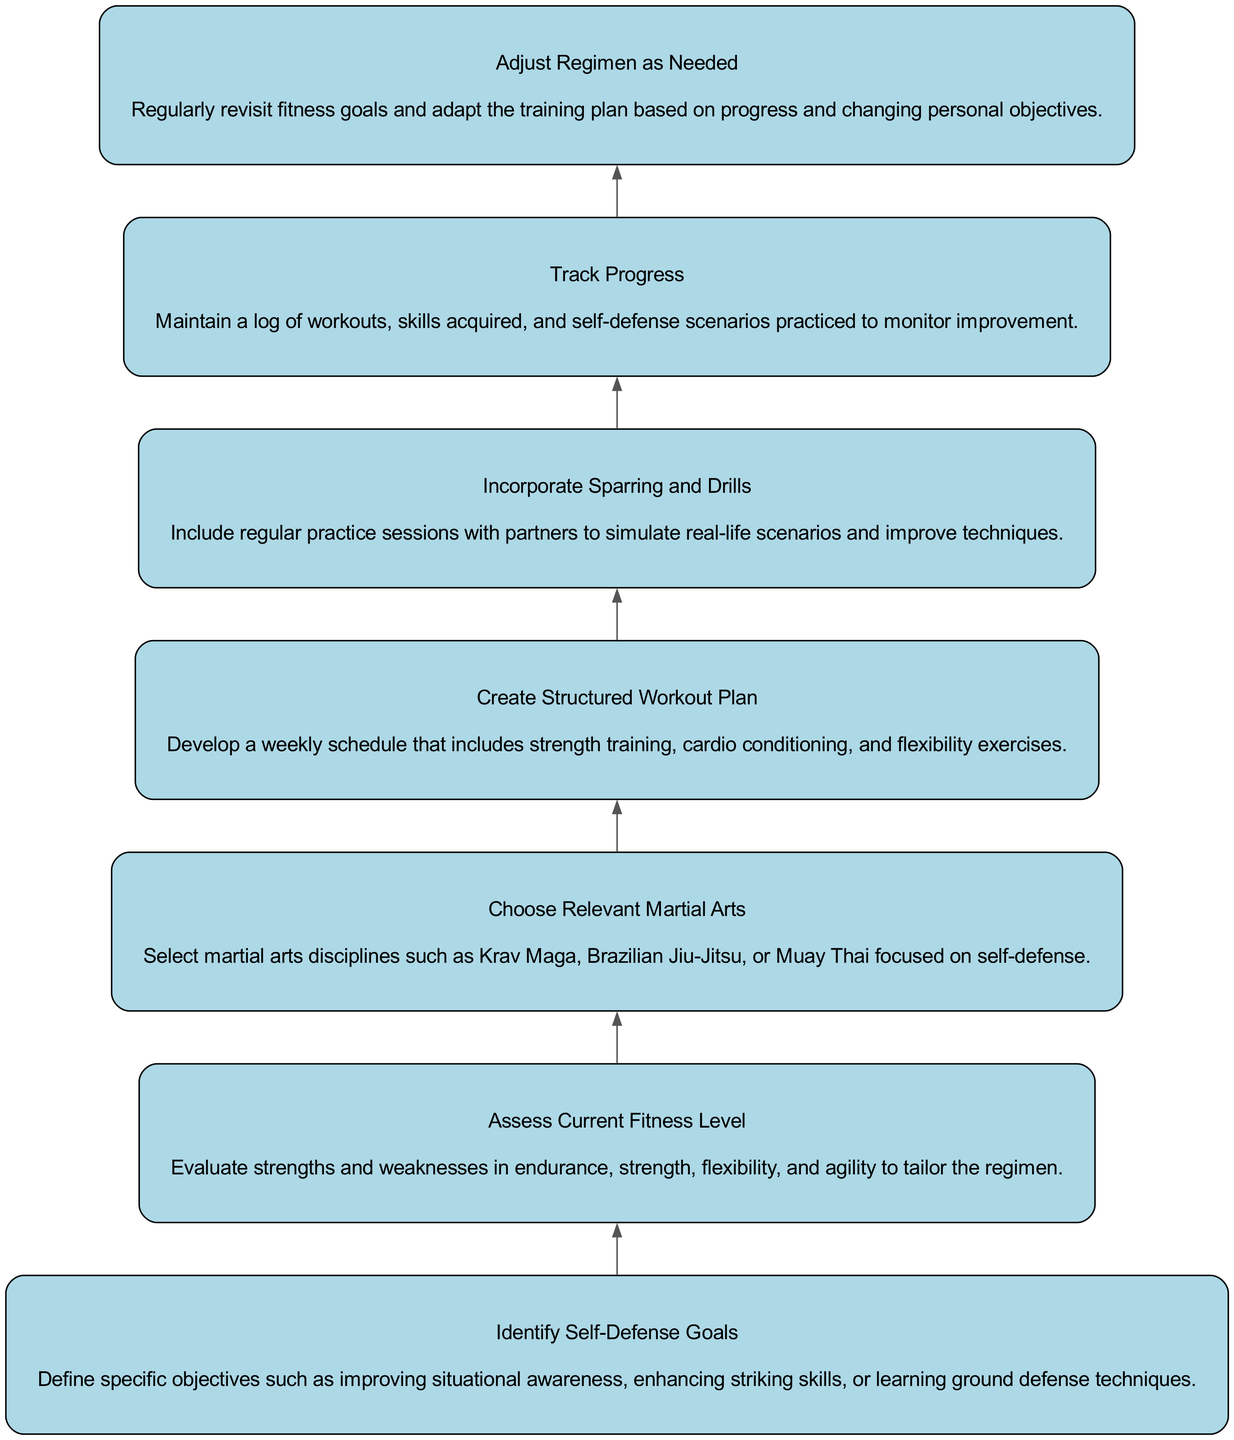What is the first step in the regimen? The diagram reveals that the first step is "Identify Self-Defense Goals," which is the starting node at the bottom of the flow.
Answer: Identify Self-Defense Goals How many elements are included in the diagram? By counting the nodes in the diagram, we see that there are seven separate elements that represent different steps in the training regimen.
Answer: 7 What is the last element in the flow? The flow chart indicates that "Adjust Regimen as Needed" is the final node, which concludes the sequential steps in the personal fitness regimen.
Answer: Adjust Regimen as Needed Which element comes after "Choose Relevant Martial Arts"? Following the step "Choose Relevant Martial Arts," the next element in the sequence is "Create Structured Workout Plan," showing the progression from martial arts selection to workout planning.
Answer: Create Structured Workout Plan Which two elements are directly connected by an edge? There is a direct edge from "Assess Current Fitness Level" to "Choose Relevant Martial Arts," indicating that the assessment directly feeds into the decision of which martial arts to choose.
Answer: Assess Current Fitness Level and Choose Relevant Martial Arts What is the purpose of "Track Progress"? "Track Progress" serves as a critical step in the regimen for monitoring improvements made throughout the training, guiding future adjustments.
Answer: Monitoring improvements How does the flow of the diagram guide the training process? The diagram illustrates a sequential flow where each step builds on the previous one, indicating that initial goal setting leads to assessment, and progressively develops towards tracking and adjustment, which is essential for effective training.
Answer: Sequential progression What connections exist between "Incorporate Sparring and Drills" and other elements? "Incorporate Sparring and Drills" is a central part of the training, connecting back to both "Create Structured Workout Plan" for implementation and "Track Progress" to assess the outcomes of practical application.
Answer: Connects to Create Structured Workout Plan and Track Progress What should be done after assessing current fitness level? The diagram shows that after "Assess Current Fitness Level," one should "Choose Relevant Martial Arts," marking the transition from evaluation to strategic selection in training.
Answer: Choose Relevant Martial Arts 